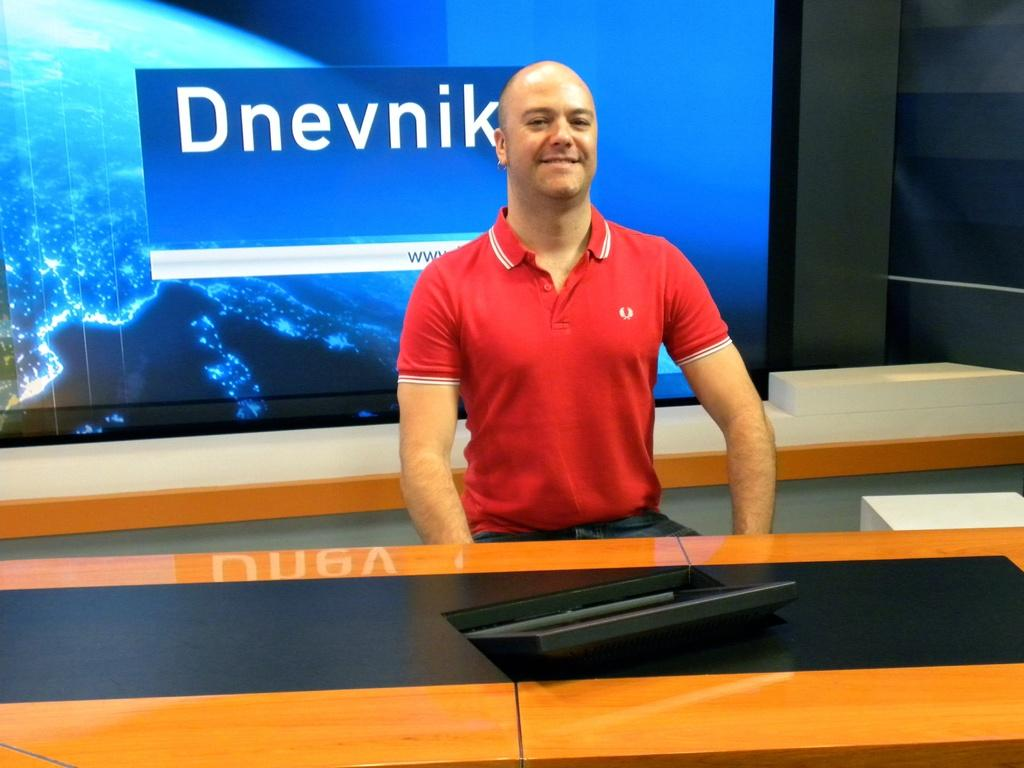<image>
Relay a brief, clear account of the picture shown. A man in a red shirt stands in front of a sign that says "Dnevnik". 